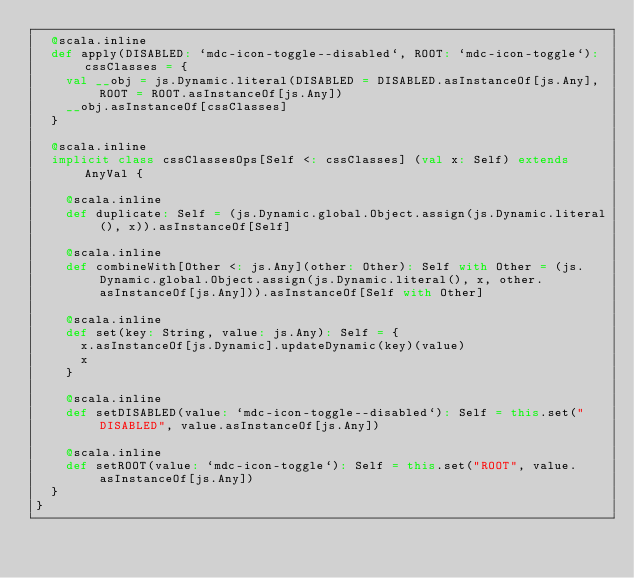Convert code to text. <code><loc_0><loc_0><loc_500><loc_500><_Scala_>  @scala.inline
  def apply(DISABLED: `mdc-icon-toggle--disabled`, ROOT: `mdc-icon-toggle`): cssClasses = {
    val __obj = js.Dynamic.literal(DISABLED = DISABLED.asInstanceOf[js.Any], ROOT = ROOT.asInstanceOf[js.Any])
    __obj.asInstanceOf[cssClasses]
  }
  
  @scala.inline
  implicit class cssClassesOps[Self <: cssClasses] (val x: Self) extends AnyVal {
    
    @scala.inline
    def duplicate: Self = (js.Dynamic.global.Object.assign(js.Dynamic.literal(), x)).asInstanceOf[Self]
    
    @scala.inline
    def combineWith[Other <: js.Any](other: Other): Self with Other = (js.Dynamic.global.Object.assign(js.Dynamic.literal(), x, other.asInstanceOf[js.Any])).asInstanceOf[Self with Other]
    
    @scala.inline
    def set(key: String, value: js.Any): Self = {
      x.asInstanceOf[js.Dynamic].updateDynamic(key)(value)
      x
    }
    
    @scala.inline
    def setDISABLED(value: `mdc-icon-toggle--disabled`): Self = this.set("DISABLED", value.asInstanceOf[js.Any])
    
    @scala.inline
    def setROOT(value: `mdc-icon-toggle`): Self = this.set("ROOT", value.asInstanceOf[js.Any])
  }
}
</code> 